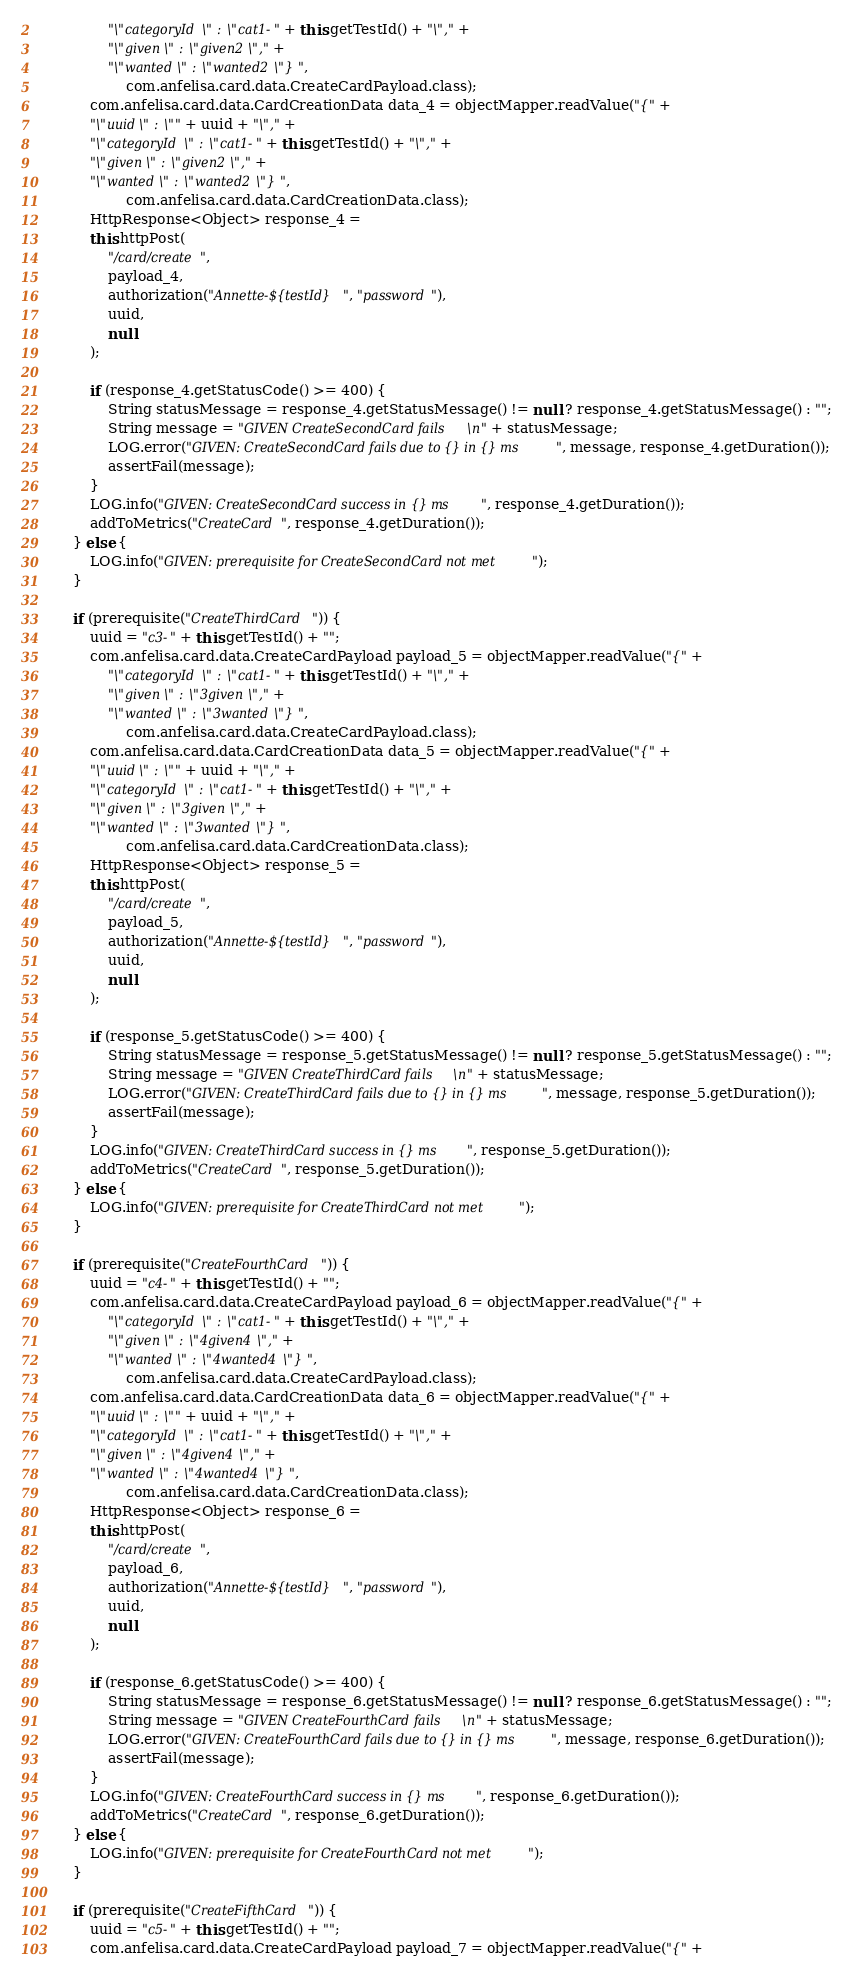Convert code to text. <code><loc_0><loc_0><loc_500><loc_500><_Java_>				"\"categoryId\" : \"cat1-" + this.getTestId() + "\"," + 
				"\"given\" : \"given2\"," + 
				"\"wanted\" : \"wanted2\"} ",
					com.anfelisa.card.data.CreateCardPayload.class);
			com.anfelisa.card.data.CardCreationData data_4 = objectMapper.readValue("{" +
			"\"uuid\" : \"" + uuid + "\"," + 
			"\"categoryId\" : \"cat1-" + this.getTestId() + "\"," + 
			"\"given\" : \"given2\"," + 
			"\"wanted\" : \"wanted2\"} ",
					com.anfelisa.card.data.CardCreationData.class);
			HttpResponse<Object> response_4 = 
			this.httpPost(
				"/card/create", 
			 	payload_4,
				authorization("Annette-${testId}", "password"),
				uuid,
				null
			);
			
			if (response_4.getStatusCode() >= 400) {
				String statusMessage = response_4.getStatusMessage() != null ? response_4.getStatusMessage() : "";
				String message = "GIVEN CreateSecondCard fails\n" + statusMessage;
				LOG.error("GIVEN: CreateSecondCard fails due to {} in {} ms", message, response_4.getDuration());
				assertFail(message);
			}
			LOG.info("GIVEN: CreateSecondCard success in {} ms", response_4.getDuration());
			addToMetrics("CreateCard", response_4.getDuration());
		} else {
			LOG.info("GIVEN: prerequisite for CreateSecondCard not met");
		}

		if (prerequisite("CreateThirdCard")) {
			uuid = "c3-" + this.getTestId() + "";
			com.anfelisa.card.data.CreateCardPayload payload_5 = objectMapper.readValue("{" +
				"\"categoryId\" : \"cat1-" + this.getTestId() + "\"," + 
				"\"given\" : \"3given\"," + 
				"\"wanted\" : \"3wanted\"} ",
					com.anfelisa.card.data.CreateCardPayload.class);
			com.anfelisa.card.data.CardCreationData data_5 = objectMapper.readValue("{" +
			"\"uuid\" : \"" + uuid + "\"," + 
			"\"categoryId\" : \"cat1-" + this.getTestId() + "\"," + 
			"\"given\" : \"3given\"," + 
			"\"wanted\" : \"3wanted\"} ",
					com.anfelisa.card.data.CardCreationData.class);
			HttpResponse<Object> response_5 = 
			this.httpPost(
				"/card/create", 
			 	payload_5,
				authorization("Annette-${testId}", "password"),
				uuid,
				null
			);
			
			if (response_5.getStatusCode() >= 400) {
				String statusMessage = response_5.getStatusMessage() != null ? response_5.getStatusMessage() : "";
				String message = "GIVEN CreateThirdCard fails\n" + statusMessage;
				LOG.error("GIVEN: CreateThirdCard fails due to {} in {} ms", message, response_5.getDuration());
				assertFail(message);
			}
			LOG.info("GIVEN: CreateThirdCard success in {} ms", response_5.getDuration());
			addToMetrics("CreateCard", response_5.getDuration());
		} else {
			LOG.info("GIVEN: prerequisite for CreateThirdCard not met");
		}

		if (prerequisite("CreateFourthCard")) {
			uuid = "c4-" + this.getTestId() + "";
			com.anfelisa.card.data.CreateCardPayload payload_6 = objectMapper.readValue("{" +
				"\"categoryId\" : \"cat1-" + this.getTestId() + "\"," + 
				"\"given\" : \"4given4\"," + 
				"\"wanted\" : \"4wanted4\"} ",
					com.anfelisa.card.data.CreateCardPayload.class);
			com.anfelisa.card.data.CardCreationData data_6 = objectMapper.readValue("{" +
			"\"uuid\" : \"" + uuid + "\"," + 
			"\"categoryId\" : \"cat1-" + this.getTestId() + "\"," + 
			"\"given\" : \"4given4\"," + 
			"\"wanted\" : \"4wanted4\"} ",
					com.anfelisa.card.data.CardCreationData.class);
			HttpResponse<Object> response_6 = 
			this.httpPost(
				"/card/create", 
			 	payload_6,
				authorization("Annette-${testId}", "password"),
				uuid,
				null
			);
			
			if (response_6.getStatusCode() >= 400) {
				String statusMessage = response_6.getStatusMessage() != null ? response_6.getStatusMessage() : "";
				String message = "GIVEN CreateFourthCard fails\n" + statusMessage;
				LOG.error("GIVEN: CreateFourthCard fails due to {} in {} ms", message, response_6.getDuration());
				assertFail(message);
			}
			LOG.info("GIVEN: CreateFourthCard success in {} ms", response_6.getDuration());
			addToMetrics("CreateCard", response_6.getDuration());
		} else {
			LOG.info("GIVEN: prerequisite for CreateFourthCard not met");
		}

		if (prerequisite("CreateFifthCard")) {
			uuid = "c5-" + this.getTestId() + "";
			com.anfelisa.card.data.CreateCardPayload payload_7 = objectMapper.readValue("{" +</code> 